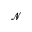<formula> <loc_0><loc_0><loc_500><loc_500>\mathcal { N }</formula> 